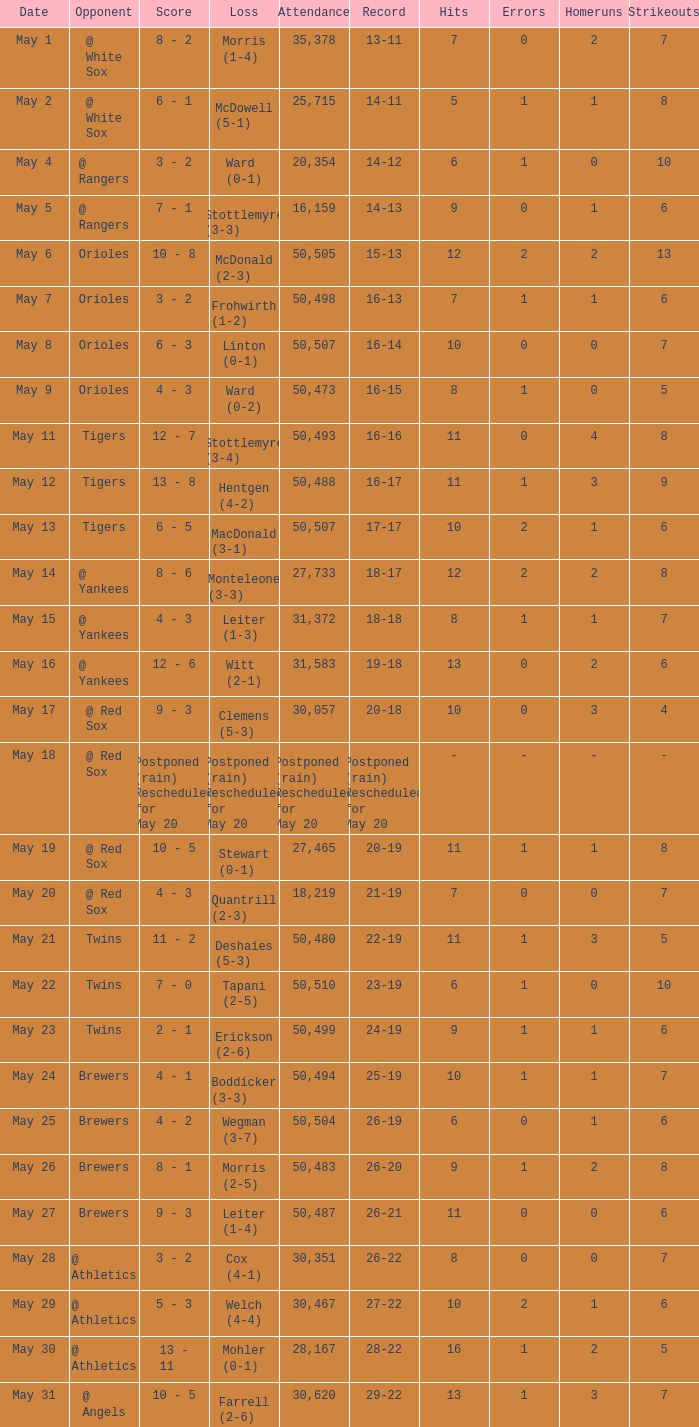Can you parse all the data within this table? {'header': ['Date', 'Opponent', 'Score', 'Loss', 'Attendance', 'Record', 'Hits', 'Errors', 'Homeruns', 'Strikeouts'], 'rows': [['May 1', '@ White Sox', '8 - 2', 'Morris (1-4)', '35,378', '13-11', '7', '0', '2', '7'], ['May 2', '@ White Sox', '6 - 1', 'McDowell (5-1)', '25,715', '14-11', '5', '1', '1', '8'], ['May 4', '@ Rangers', '3 - 2', 'Ward (0-1)', '20,354', '14-12', '6', '1', '0', '10'], ['May 5', '@ Rangers', '7 - 1', 'Stottlemyre (3-3)', '16,159', '14-13', '9', '0', '1', '6'], ['May 6', 'Orioles', '10 - 8', 'McDonald (2-3)', '50,505', '15-13', '12', '2', '2', '13'], ['May 7', 'Orioles', '3 - 2', 'Frohwirth (1-2)', '50,498', '16-13', '7', '1', '1', '6'], ['May 8', 'Orioles', '6 - 3', 'Linton (0-1)', '50,507', '16-14', '10', '0', '0', '7'], ['May 9', 'Orioles', '4 - 3', 'Ward (0-2)', '50,473', '16-15', '8', '1', '0', '5'], ['May 11', 'Tigers', '12 - 7', 'Stottlemyre (3-4)', '50,493', '16-16', '11', '0', '4', '8'], ['May 12', 'Tigers', '13 - 8', 'Hentgen (4-2)', '50,488', '16-17', '11', '1', '3', '9'], ['May 13', 'Tigers', '6 - 5', 'MacDonald (3-1)', '50,507', '17-17', '10', '2', '1', '6'], ['May 14', '@ Yankees', '8 - 6', 'Monteleone (3-3)', '27,733', '18-17', '12', '2', '2', '8'], ['May 15', '@ Yankees', '4 - 3', 'Leiter (1-3)', '31,372', '18-18', '8', '1', '1', '7'], ['May 16', '@ Yankees', '12 - 6', 'Witt (2-1)', '31,583', '19-18', '13', '0', '2', '6'], ['May 17', '@ Red Sox', '9 - 3', 'Clemens (5-3)', '30,057', '20-18', '10', '0', '3', '4'], ['May 18', '@ Red Sox', 'Postponed (rain) Rescheduled for May 20', 'Postponed (rain) Rescheduled for May 20', 'Postponed (rain) Rescheduled for May 20', 'Postponed (rain) Rescheduled for May 20', '-', '-', '-', '-'], ['May 19', '@ Red Sox', '10 - 5', 'Stewart (0-1)', '27,465', '20-19', '11', '1', '1', '8'], ['May 20', '@ Red Sox', '4 - 3', 'Quantrill (2-3)', '18,219', '21-19', '7', '0', '0', '7'], ['May 21', 'Twins', '11 - 2', 'Deshaies (5-3)', '50,480', '22-19', '11', '1', '3', '5'], ['May 22', 'Twins', '7 - 0', 'Tapani (2-5)', '50,510', '23-19', '6', '1', '0', '10'], ['May 23', 'Twins', '2 - 1', 'Erickson (2-6)', '50,499', '24-19', '9', '1', '1', '6'], ['May 24', 'Brewers', '4 - 1', 'Boddicker (3-3)', '50,494', '25-19', '10', '1', '1', '7'], ['May 25', 'Brewers', '4 - 2', 'Wegman (3-7)', '50,504', '26-19', '6', '0', '1', '6'], ['May 26', 'Brewers', '8 - 1', 'Morris (2-5)', '50,483', '26-20', '9', '1', '2', '8'], ['May 27', 'Brewers', '9 - 3', 'Leiter (1-4)', '50,487', '26-21', '11', '0', '0', '6'], ['May 28', '@ Athletics', '3 - 2', 'Cox (4-1)', '30,351', '26-22', '8', '0', '0', '7'], ['May 29', '@ Athletics', '5 - 3', 'Welch (4-4)', '30,467', '27-22', '10', '2', '1', '6'], ['May 30', '@ Athletics', '13 - 11', 'Mohler (0-1)', '28,167', '28-22', '16', '1', '2', '5'], ['May 31', '@ Angels', '10 - 5', 'Farrell (2-6)', '30,620', '29-22', '13', '1', '3', '7']]} What was the score of the game played on May 9? 4 - 3. 